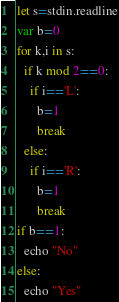<code> <loc_0><loc_0><loc_500><loc_500><_Nim_>let s=stdin.readline
var b=0
for k,i in s:
  if k mod 2==0:
    if i=='L':
      b=1
      break
  else:
    if i=='R':
      b=1
      break
if b==1:
  echo "No"
else:
  echo "Yes"</code> 